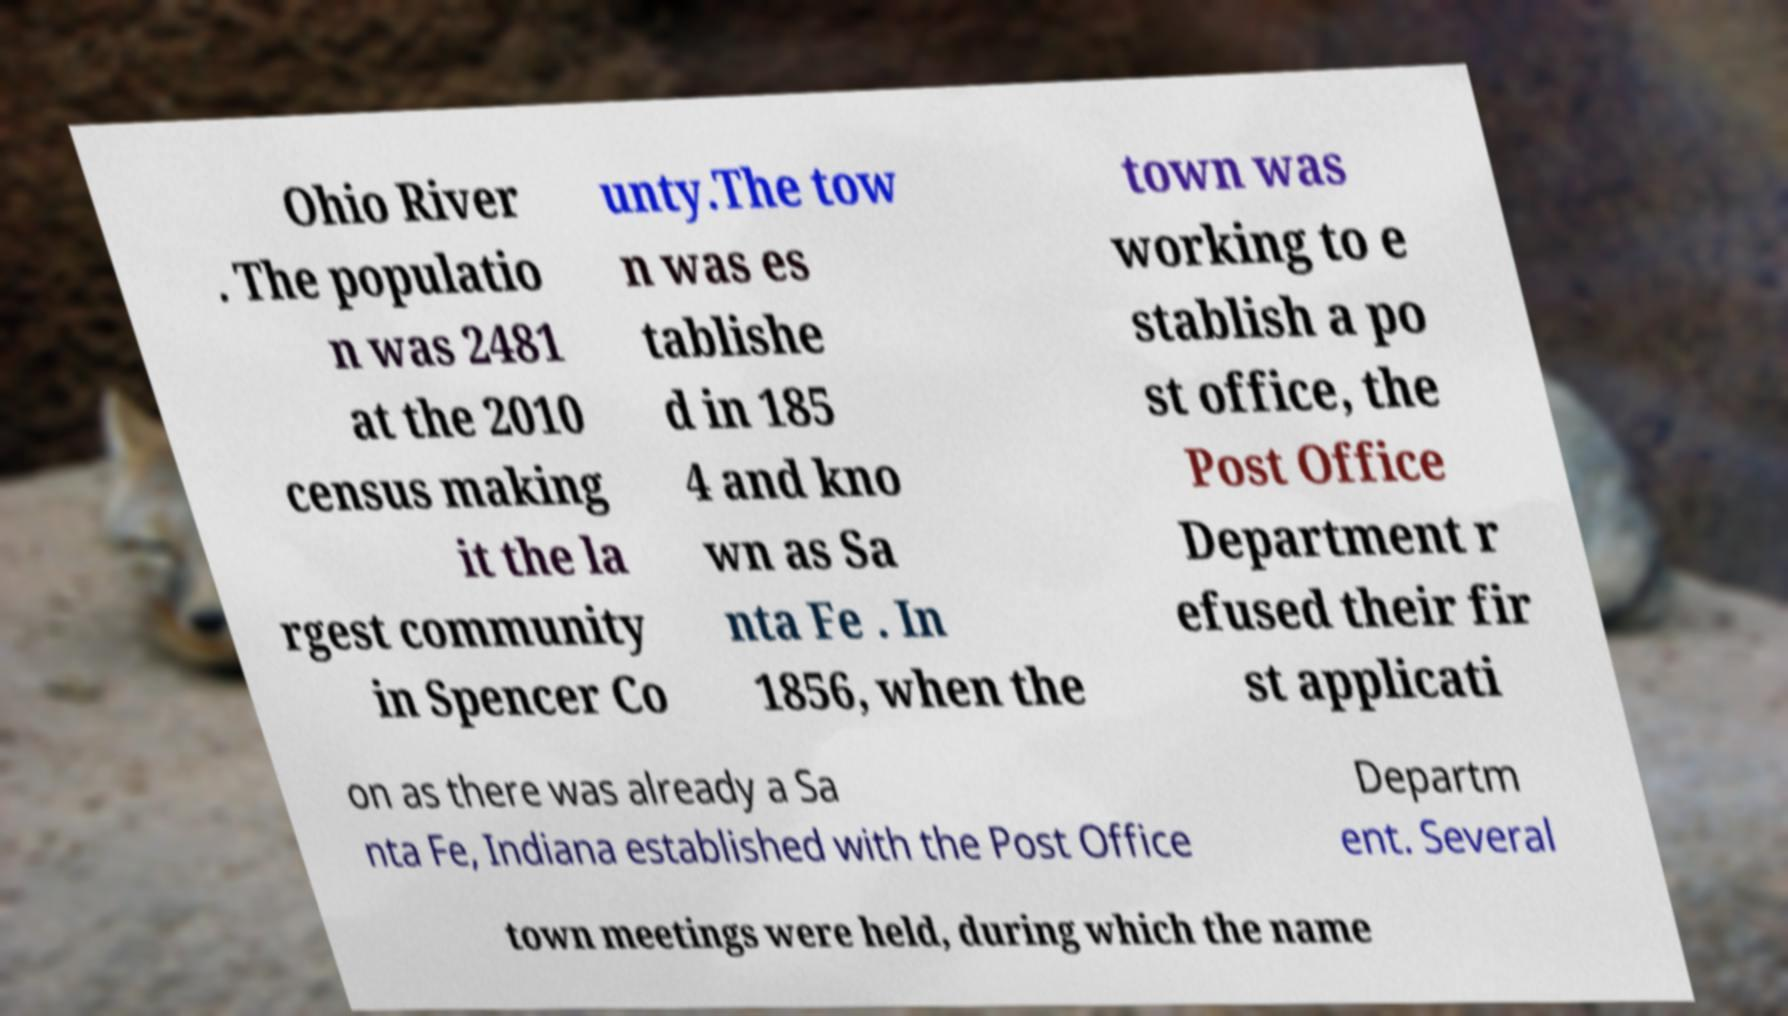For documentation purposes, I need the text within this image transcribed. Could you provide that? Ohio River . The populatio n was 2481 at the 2010 census making it the la rgest community in Spencer Co unty.The tow n was es tablishe d in 185 4 and kno wn as Sa nta Fe . In 1856, when the town was working to e stablish a po st office, the Post Office Department r efused their fir st applicati on as there was already a Sa nta Fe, Indiana established with the Post Office Departm ent. Several town meetings were held, during which the name 